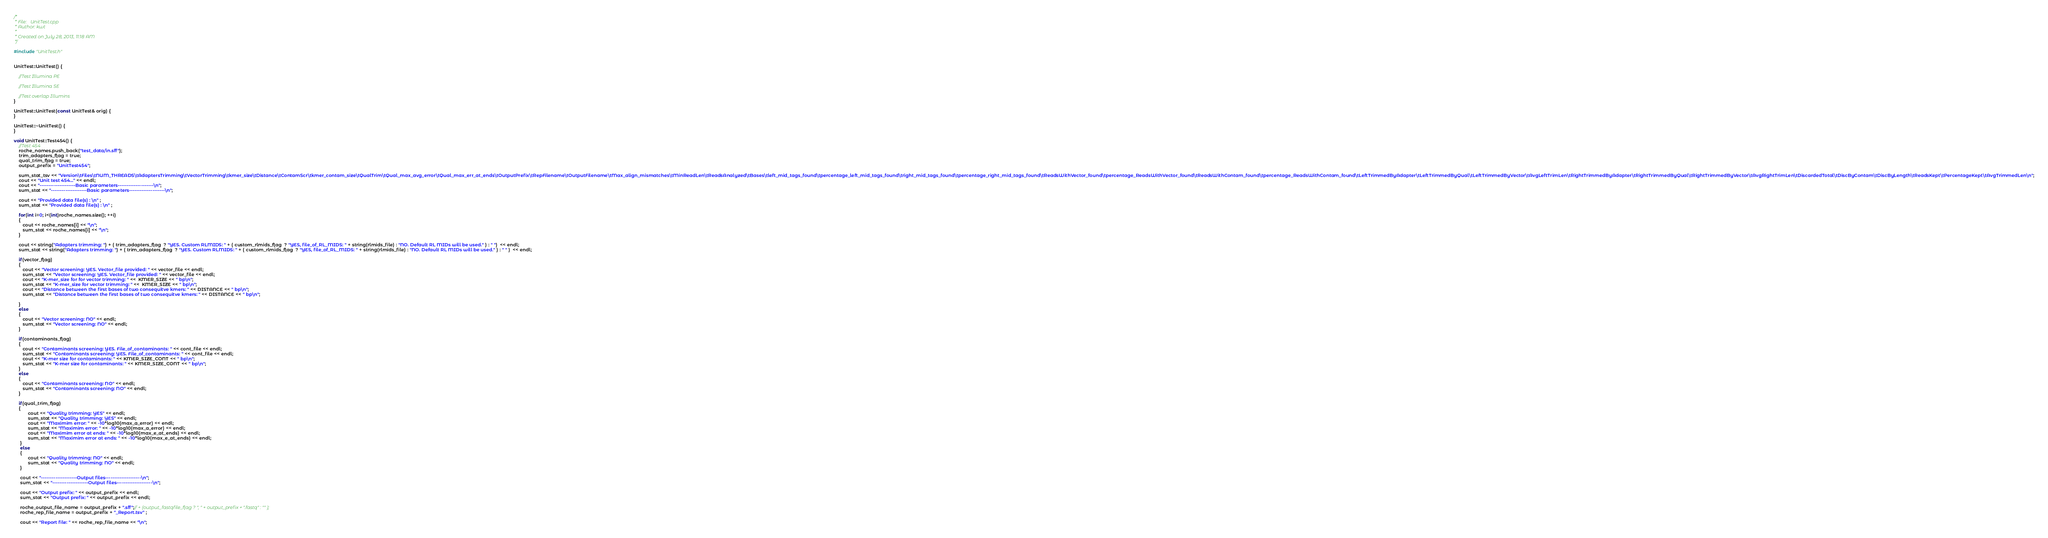<code> <loc_0><loc_0><loc_500><loc_500><_C++_>/* 
 * File:   UnitTest.cpp
 * Author: kwt
 * 
 * Created on July 28, 2013, 11:18 AM
 */

#include "UnitTest.h"


UnitTest::UnitTest() {
     
    //Test Illumina PE
    
    //Test Illumina SE
    
    //Test overlap Illumins
}

UnitTest::UnitTest(const UnitTest& orig) {
}

UnitTest::~UnitTest() {
}

void UnitTest::Test454() {
    //Test 454
    roche_names.push_back("test_data/in.sff");
    trim_adapters_flag = true;
    qual_trim_flag = true;
    output_prefix = "UnitTest454";
            
    sum_stat_tsv << "Version\tFiles\tNUM_THREADS\tAdaptersTrimming\tVectorTrimming\tkmer_size\tDistance\tContamScr\tkmer_contam_size\tQualTrim\tQual_max_avg_error\tQual_max_err_at_ends\tOutputPrefix\tRepFilename\tOutputFilename\tMax_align_mismatches\tMinReadLen\tReadsAnalyzed\tBases\tleft_mid_tags_found\tpercentage_left_mid_tags_found\tright_mid_tags_found\tpercentage_right_mid_tags_found\tReadsWithVector_found\tpercentage_ReadsWithVector_found\tReadsWithContam_found\tpercentage_ReadsWithContam_found\tLeftTrimmedByAdapter\tLeftTrimmedByQual\tLeftTrimmedByVector\tAvgLeftTrimLen\tRightTrimmedByAdapter\tRightTrimmedByQual\tRightTrimmedByVector\tAvgRightTrimLen\tDiscardedTotal\tDiscByContam\tDiscByLength\tReadsKept\tPercentageKept\tAvgTrimmedLen\n";
    cout << "Unit test 454..." << endl;
    cout << "--------------------Basic parameters--------------------\n";
    sum_stat << "--------------------Basic parameters--------------------\n";
        
    cout << "Provided data file(s) : \n" ;
    sum_stat << "Provided data file(s) : \n" ;
       
    for(int i=0; i<(int)roche_names.size(); ++i)
    {
       cout << roche_names[i] << "\n";
       sum_stat << roche_names[i] << "\n";
    }
    
    cout << string("Adapters trimming: ") + ( trim_adapters_flag  ? "YES. Custom RLMIDS: " + ( custom_rlmids_flag  ? "YES, file_of_RL_MIDS: " + string(rlmids_file) : "NO. Default RL MIDs will be used." ) : " ")  << endl;
    sum_stat << string("Adapters trimming: ") + ( trim_adapters_flag  ? "YES. Custom RLMIDS: " + ( custom_rlmids_flag  ? "YES, file_of_RL_MIDS: " + string(rlmids_file) : "NO. Default RL MIDs will be used." ) : " " )  << endl;
        
    if(vector_flag)
    {
       cout << "Vector screening: YES. Vector_file provided: " << vector_file << endl;
       sum_stat << "Vector screening: YES. Vector_file provided: " << vector_file << endl;
       cout << "K-mer_size for for vector trimming: " <<  KMER_SIZE << " bp\n";
       sum_stat << "K-mer_size for vector trimming: " <<  KMER_SIZE << " bp\n";
       cout << "Distance between the first bases of two consequitve kmers: " << DISTANCE << " bp\n";
       sum_stat << "Distance between the first bases of two consequitve kmers: " << DISTANCE << " bp\n";
    
    } 
    else
    {
       cout << "Vector screening: NO" << endl;
       sum_stat << "Vector screening: NO" << endl;
    }
        
    if(contaminants_flag)
    {
       cout << "Contaminants screening: YES. File_of_contaminants: " << cont_file << endl;
       sum_stat << "Contaminants screening: YES. File_of_contaminants: " << cont_file << endl;
       cout << "K-mer size for contaminants: " << KMER_SIZE_CONT << " bp\n";
       sum_stat << "K-mer size for contaminants: " << KMER_SIZE_CONT << " bp\n";
    } 
    else
    {
       cout << "Contaminants screening: NO" << endl;
       sum_stat << "Contaminants screening: NO" << endl;
    }
        
    if(qual_trim_flag)
    {
           cout << "Quality trimming: YES" << endl;
           sum_stat << "Quality trimming: YES" << endl;
           cout << "Maximim error: " << -10*log10(max_a_error) << endl;
           sum_stat << "Maximim error: " << -10*log10(max_a_error) << endl;
           cout << "Maximim error at ends: " << -10*log10(max_e_at_ends) << endl;
           sum_stat << "Maximim error at ends: " << -10*log10(max_e_at_ends) << endl;
     }
     else
     {
           cout << "Quality trimming: NO" << endl;
           sum_stat << "Quality trimming: NO" << endl;
     }
        
     cout << "--------------------Output files--------------------\n";
     sum_stat << "--------------------Output files--------------------\n";
        
     cout << "Output prefix: " << output_prefix << endl;
     sum_stat << "Output prefix: " << output_prefix << endl;
        
     roche_output_file_name = output_prefix + ".sff";// + (output_fastqfile_flag ? ", " + output_prefix + ".fastq" : "" );
     roche_rep_file_name = output_prefix + "_Report.tsv" ;
        
     cout << "Report file: " << roche_rep_file_name << "\n";</code> 